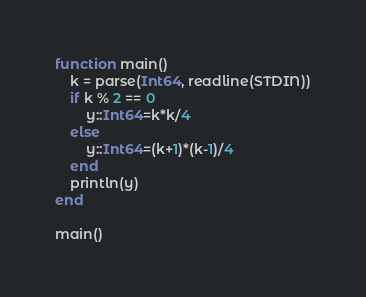Convert code to text. <code><loc_0><loc_0><loc_500><loc_500><_Julia_>function main()
	k = parse(Int64, readline(STDIN))
	if k % 2 == 0
		y::Int64=k*k/4
	else
		y::Int64=(k+1)*(k-1)/4
	end
	println(y)
end

main()</code> 